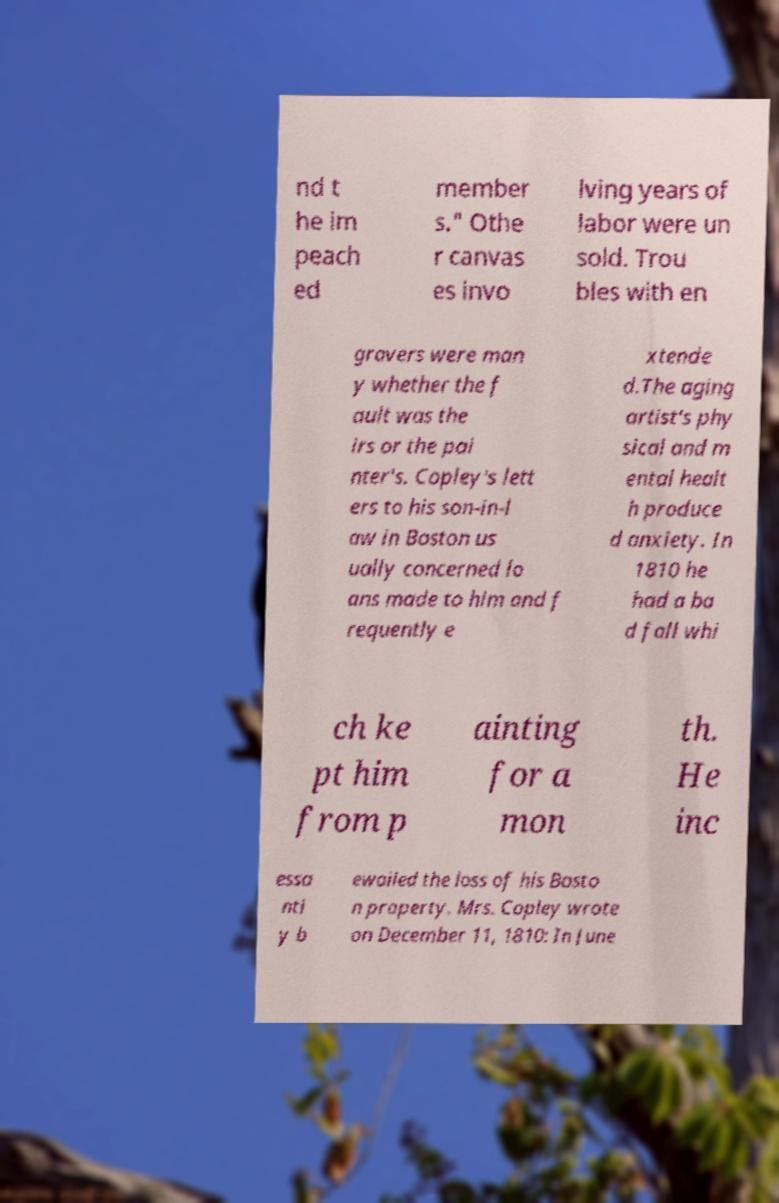Please read and relay the text visible in this image. What does it say? nd t he im peach ed member s." Othe r canvas es invo lving years of labor were un sold. Trou bles with en gravers were man y whether the f ault was the irs or the pai nter's. Copley's lett ers to his son-in-l aw in Boston us ually concerned lo ans made to him and f requently e xtende d.The aging artist's phy sical and m ental healt h produce d anxiety. In 1810 he had a ba d fall whi ch ke pt him from p ainting for a mon th. He inc essa ntl y b ewailed the loss of his Bosto n property. Mrs. Copley wrote on December 11, 1810: In June 